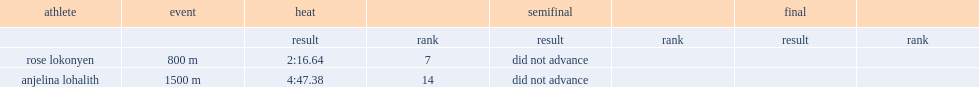What was the result that anjelina lohalith got in the 1500m in the heat? 4:47.38. 